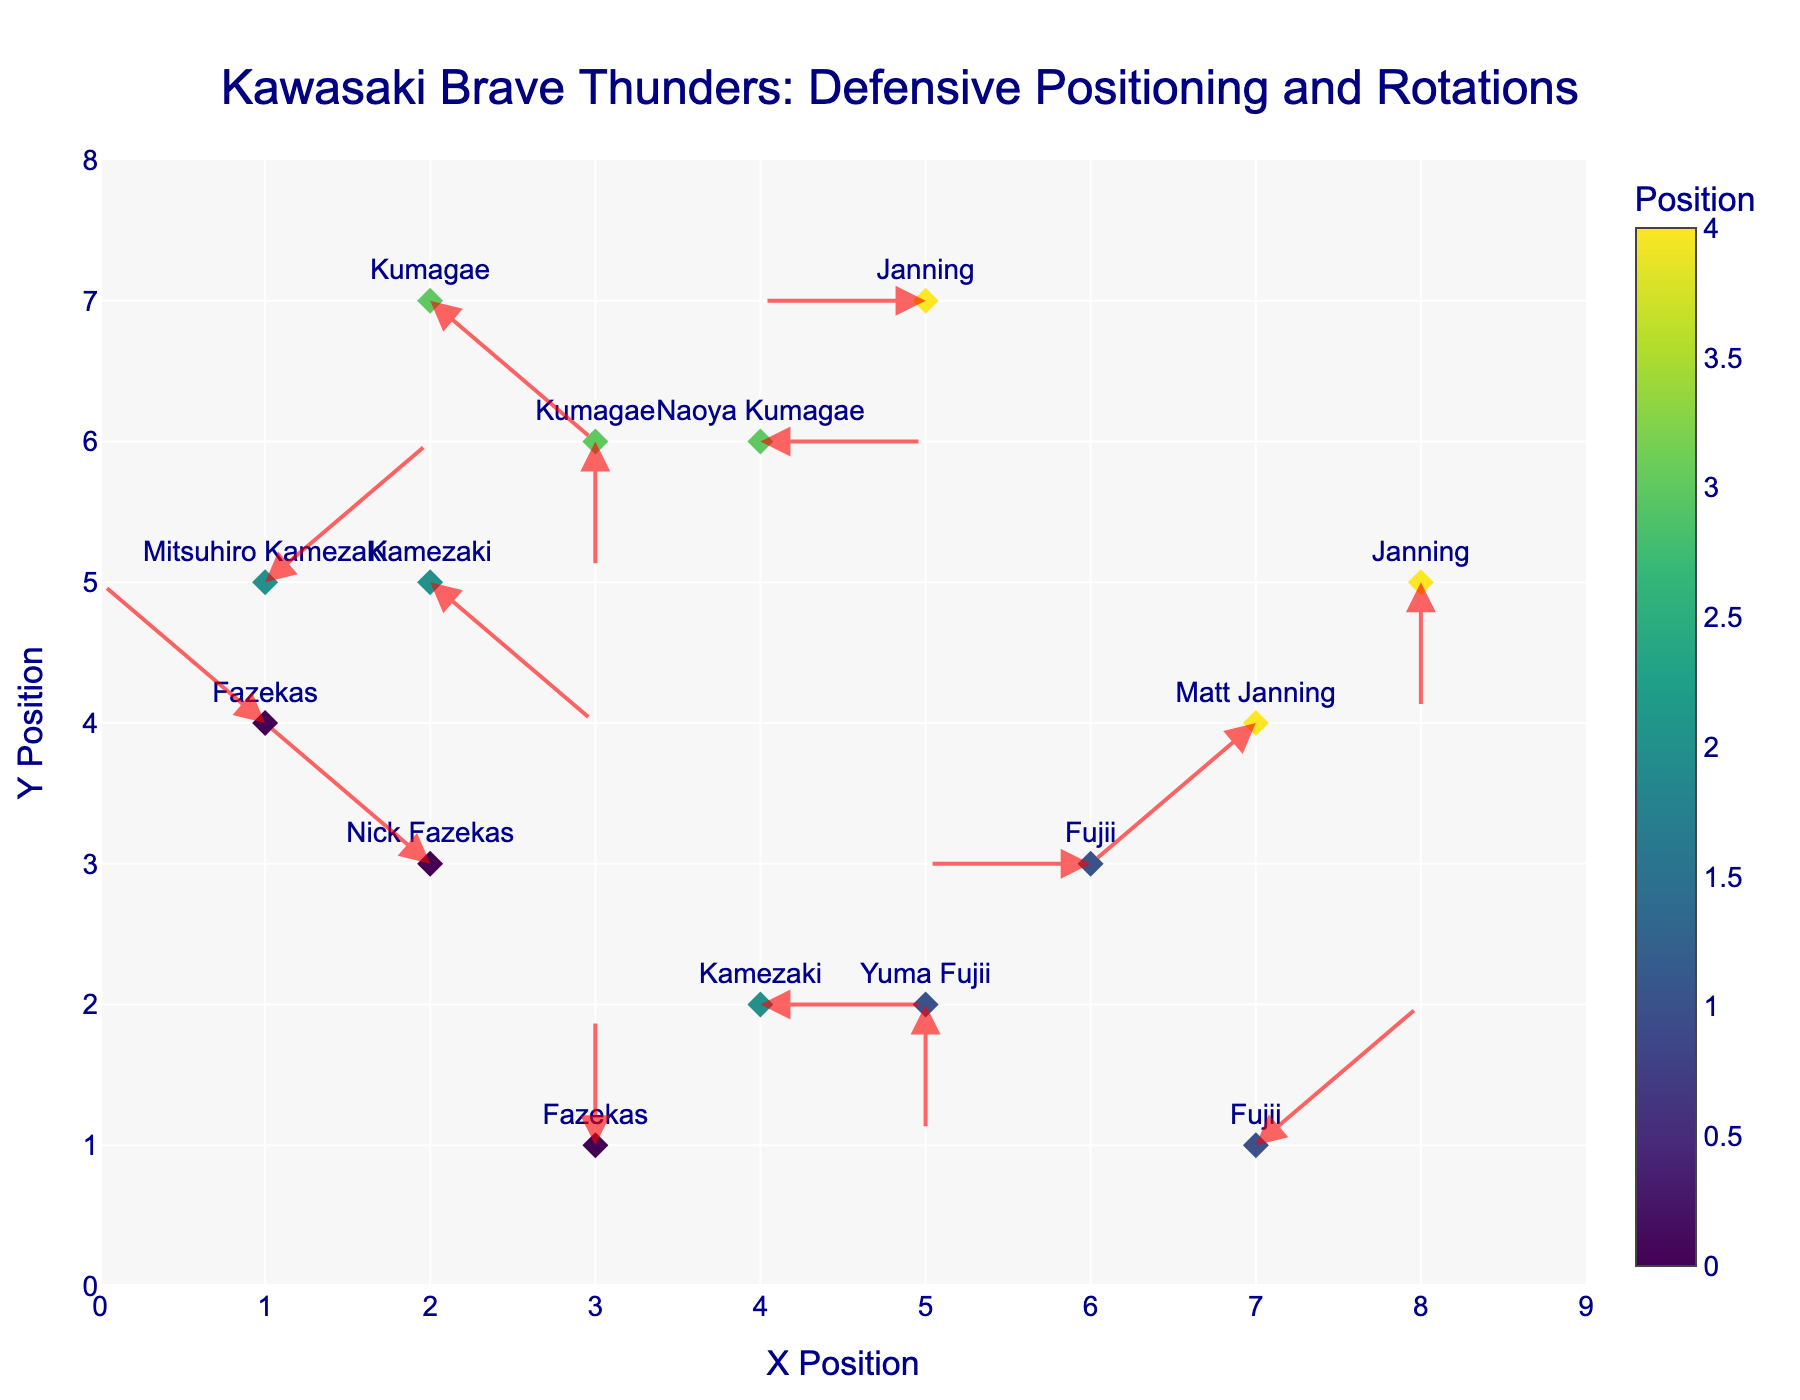What is the title of the quiver plot? The title can be found at the top of the plot.
Answer: Kawasaki Brave Thunders: Defensive Positioning and Rotations How many arrows are depicted in the plot? Each rotor vector or 'arrow' represents the movement of a player. By counting the number of arrows, we can find the answer.
Answer: 15 Which player's defensive movement is the longest? To determine this, we need to examine the length of each arrow and find the player associated with the longest one. The formula for the length of the vector \( \text{length} = \sqrt{u^2 + v^2} \) can help.
Answer: Matt Janning (7,1) -> (8,2) Which player is located at (1, 4)? By looking at the markers and matching the coordinates (1, 4) with the text labels, we can find the player.
Answer: Nick Fazekas What is the next position for Yuma Fujii located at (5, 2)? We need to look at the arrow originating from (5, 2) and calculate the target coordinates using (x + u, y + v).
Answer: (5, 1) What direction is Naoya Kumagae moving from (4, 6)? To find the direction of movement, check the arrow starting from (4, 6) and see the u and v direction values pointing to the next position.
Answer: East What is the average x-position of all Small Forwards? First, filter the Small Forwards. Add the x-coordinates and divide by the number of Small Forward players. Calculations: (7 + 8 + 5) / 3
Answer: 6.67 Which player has the most upward (positive y) movement? We need to determine which arrow has the largest positive y-component (v). Find the player corresponding to this largest positive y value.
Answer: Mitsuhiro Kamezaki at (1, 5) Compare the movements of Matt Janning and Mitsuhiro Kamezaki. Who has a stronger lateral movement? Compare the absolute values of the x-component (u) for each player's movement vectors. The higher absolute value indicates stronger lateral movement.
Answer: Matt Janning Which players have no vertical movement? Find the arrows where the y-component (v) is zero and list the associated players.
Answer: Naoya Kumagae at (4, 6) and Mitsuhiro Kamezaki at (4, 2) 